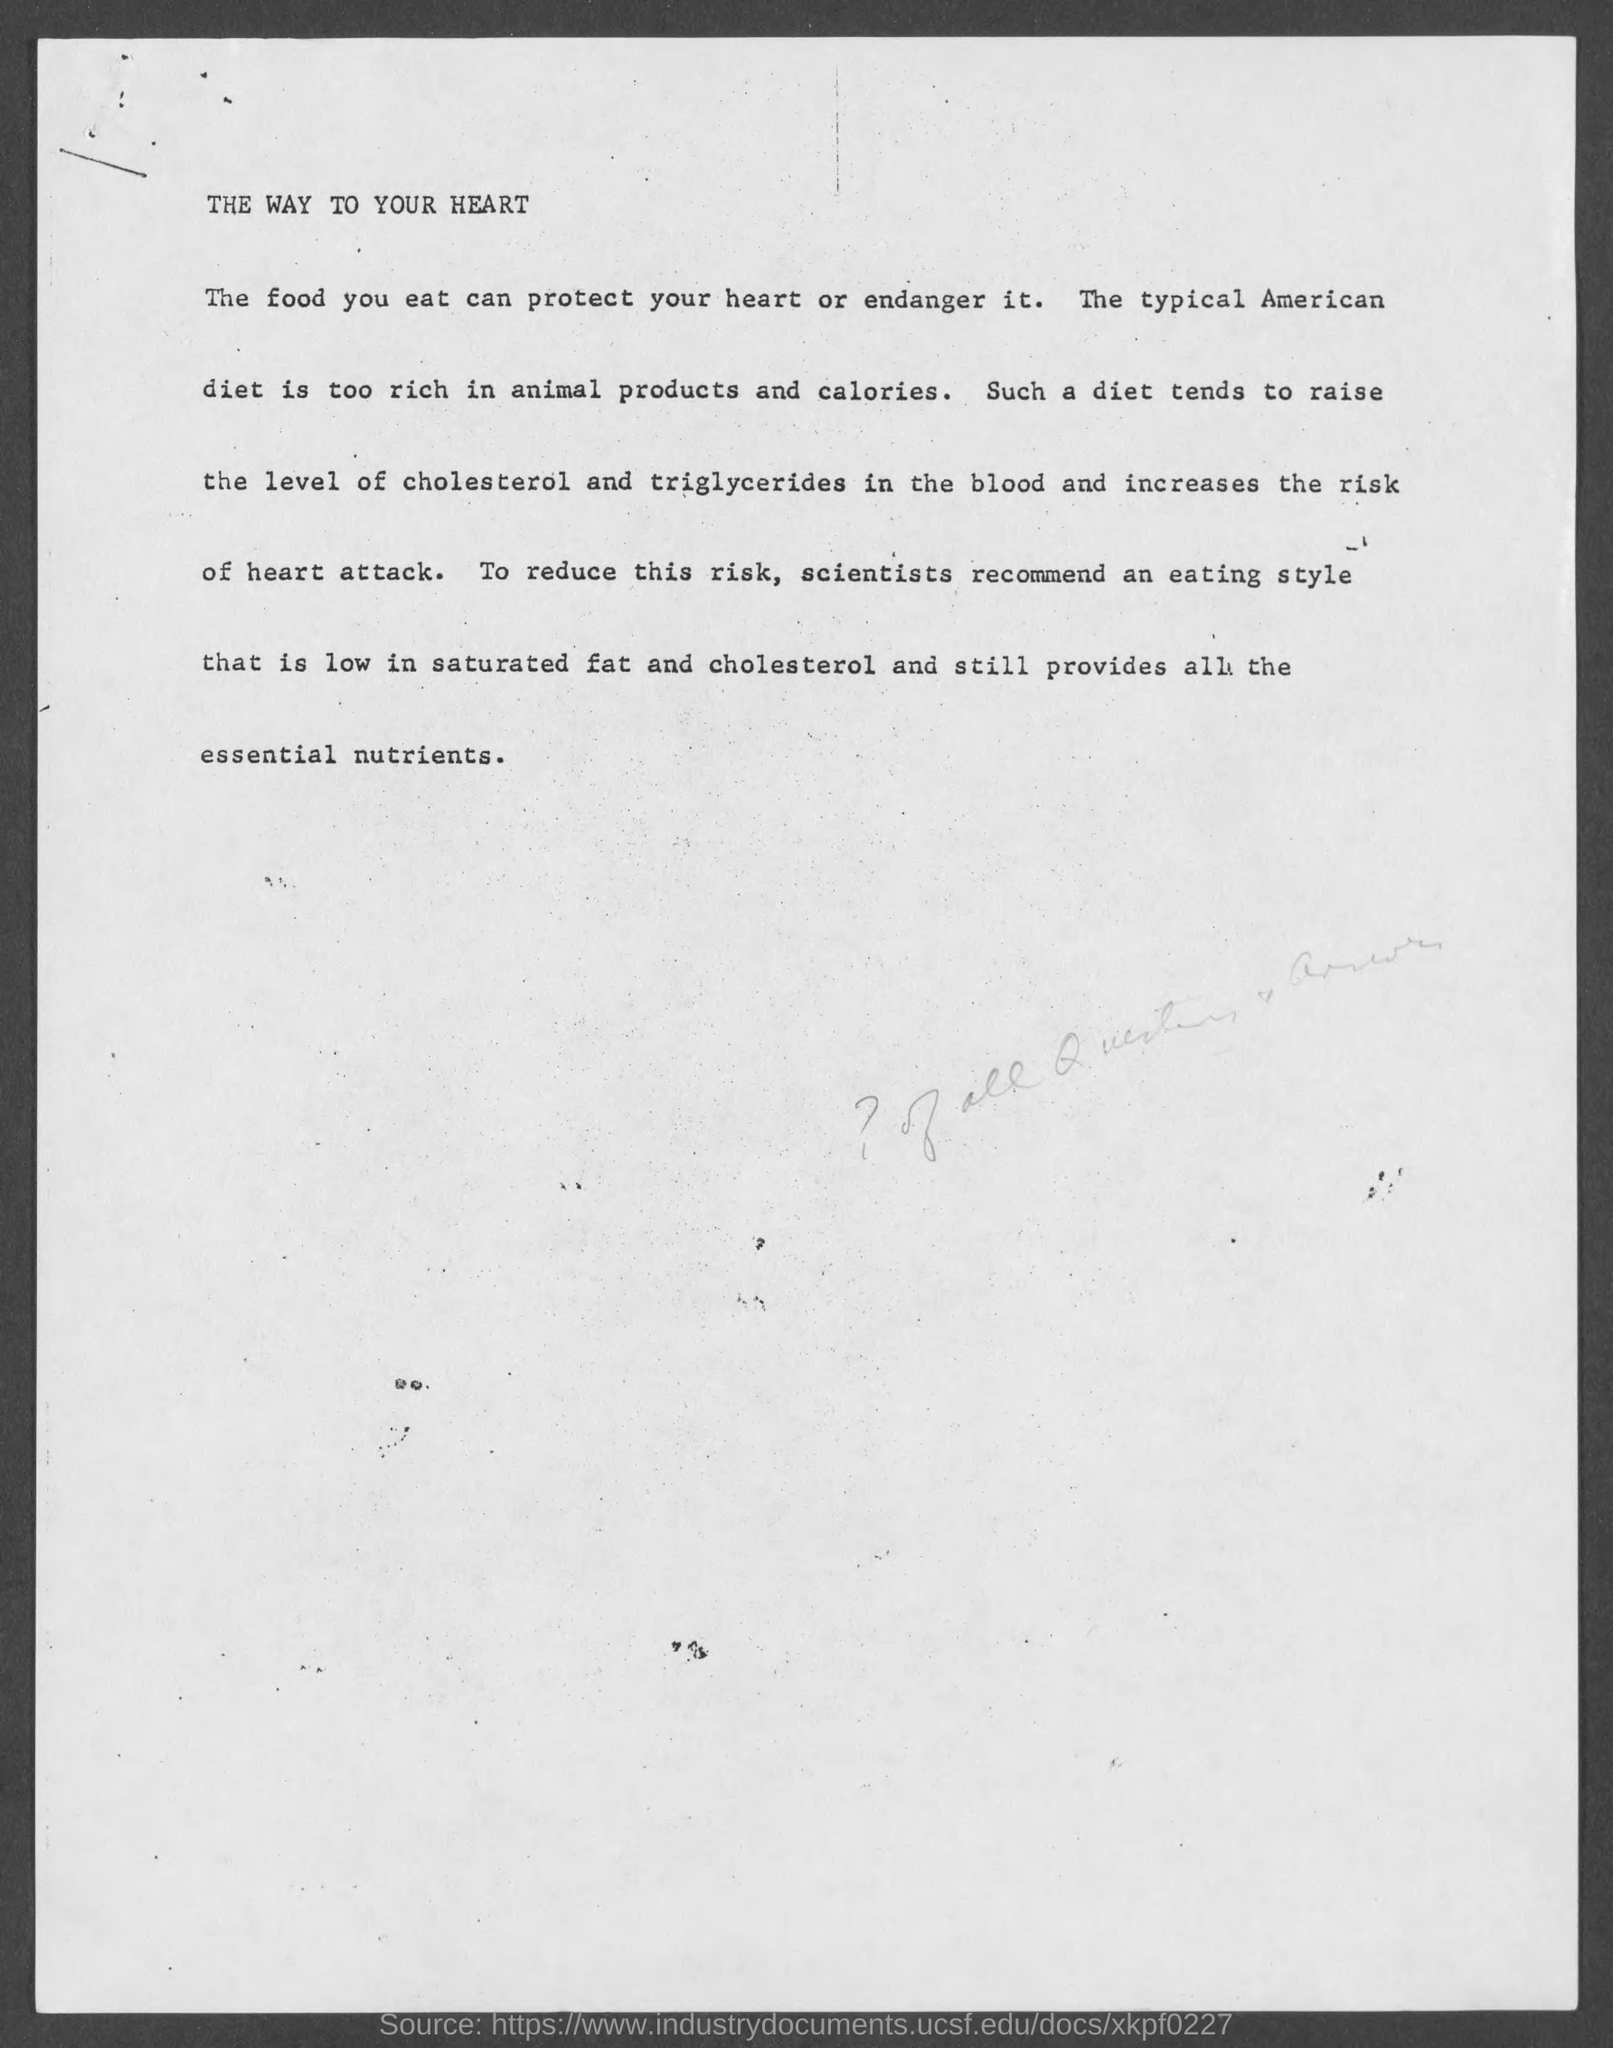What is the title of the document?
Your response must be concise. The way to your Heart. 